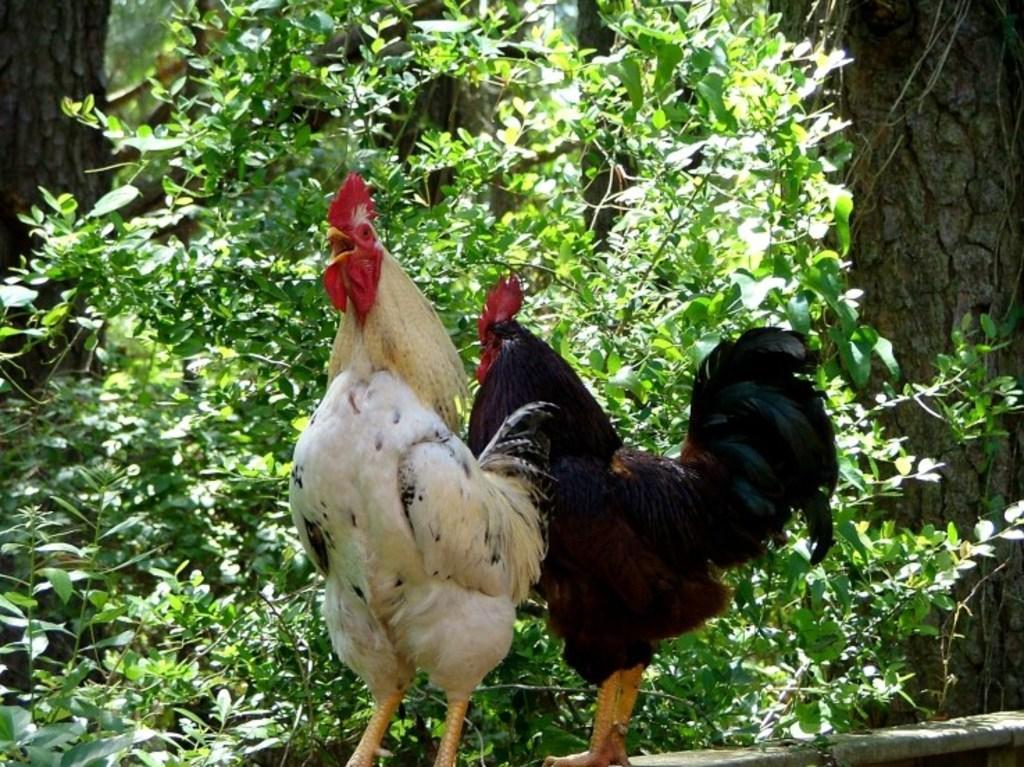Can you describe this image briefly? In this picture we can see two roosters are standing, in the background there are some trees. 